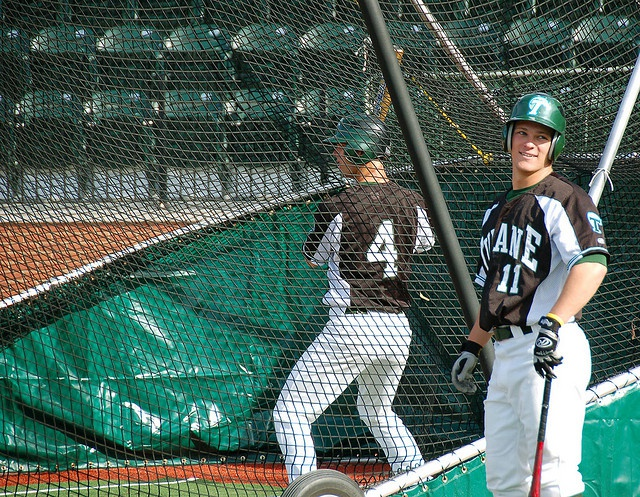Describe the objects in this image and their specific colors. I can see people in black, white, gray, and darkgray tones, people in black, white, gray, and darkgray tones, chair in black, gray, teal, and darkgreen tones, chair in black, gray, teal, and darkgreen tones, and chair in black, gray, teal, and darkgreen tones in this image. 